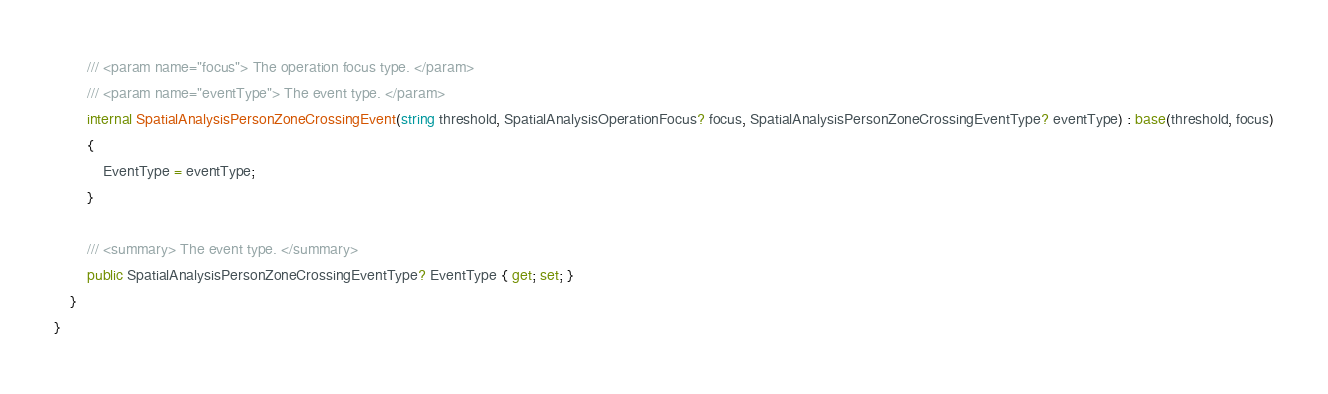Convert code to text. <code><loc_0><loc_0><loc_500><loc_500><_C#_>        /// <param name="focus"> The operation focus type. </param>
        /// <param name="eventType"> The event type. </param>
        internal SpatialAnalysisPersonZoneCrossingEvent(string threshold, SpatialAnalysisOperationFocus? focus, SpatialAnalysisPersonZoneCrossingEventType? eventType) : base(threshold, focus)
        {
            EventType = eventType;
        }

        /// <summary> The event type. </summary>
        public SpatialAnalysisPersonZoneCrossingEventType? EventType { get; set; }
    }
}
</code> 